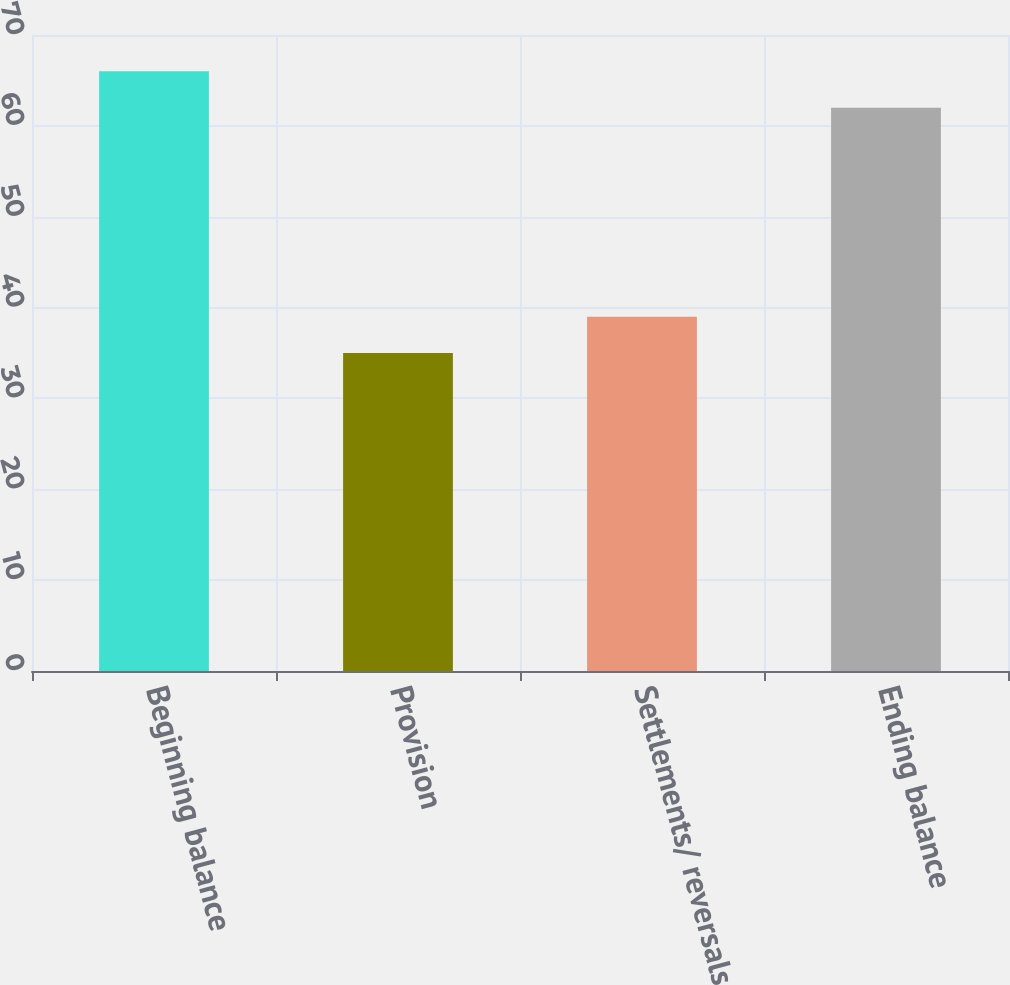Convert chart to OTSL. <chart><loc_0><loc_0><loc_500><loc_500><bar_chart><fcel>Beginning balance<fcel>Provision<fcel>Settlements/ reversals<fcel>Ending balance<nl><fcel>66<fcel>35<fcel>39<fcel>62<nl></chart> 